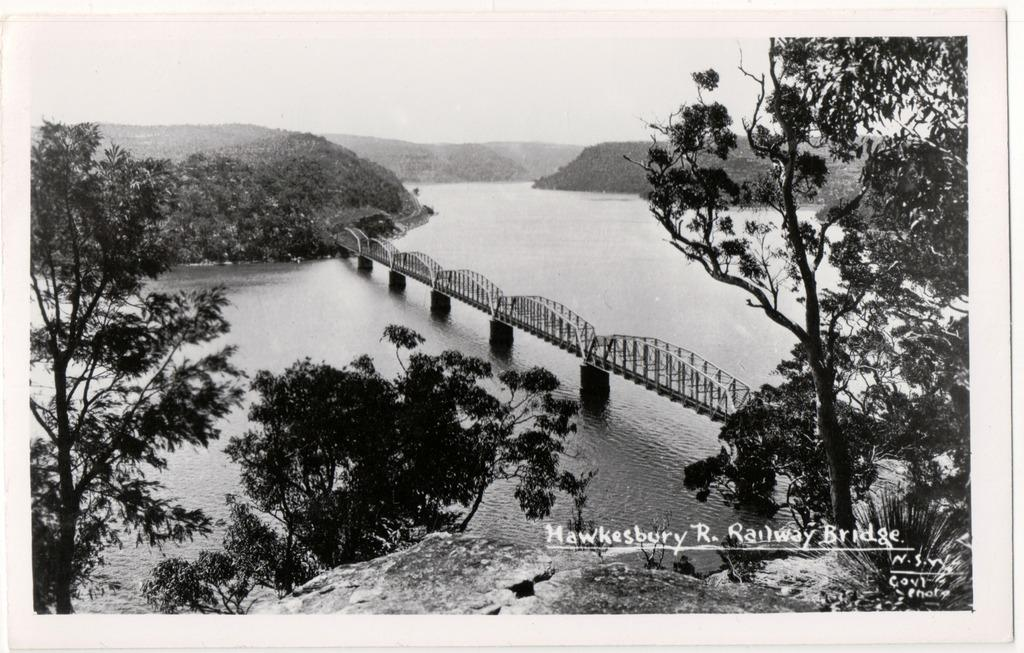What is the main subject in the center of the image? There is a poster in the center of the image. What elements are depicted on the poster? The poster contains trees, water, and a bridge. What type of floor can be seen under the poster in the image? There is no floor visible under the poster in the image; it is a poster hanging on a wall or other surface. 